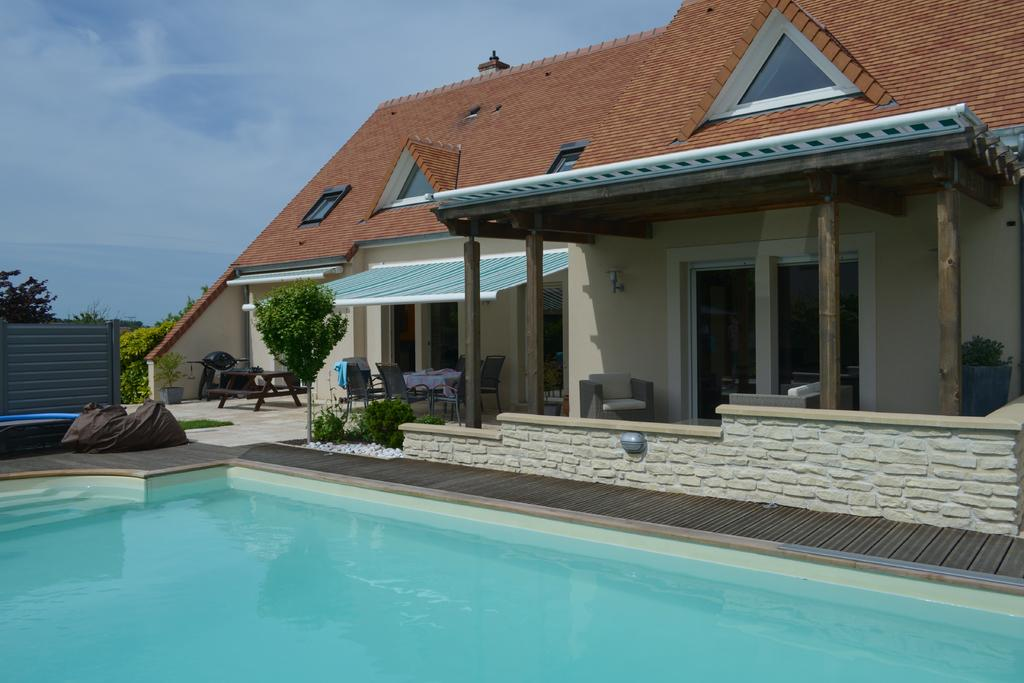What structure is located on the right side of the image? There is a building on the right side of the image. What is in front of the building? There is a dining table in front of the building. What type of vegetation is in front of the building? There are plants in front of the building. What body of water is visible in the image? There is a pool in the image. What is visible at the top of the image? The sky is visible in the image. What can be seen in the sky? Clouds are present in the sky. What type of haircut is the pool giving in the image? There is no haircut present in the image; it is a pool of water. What type of lunch is being served on the dining table in the image? There is no lunch visible in the image; only a dining table is present. 